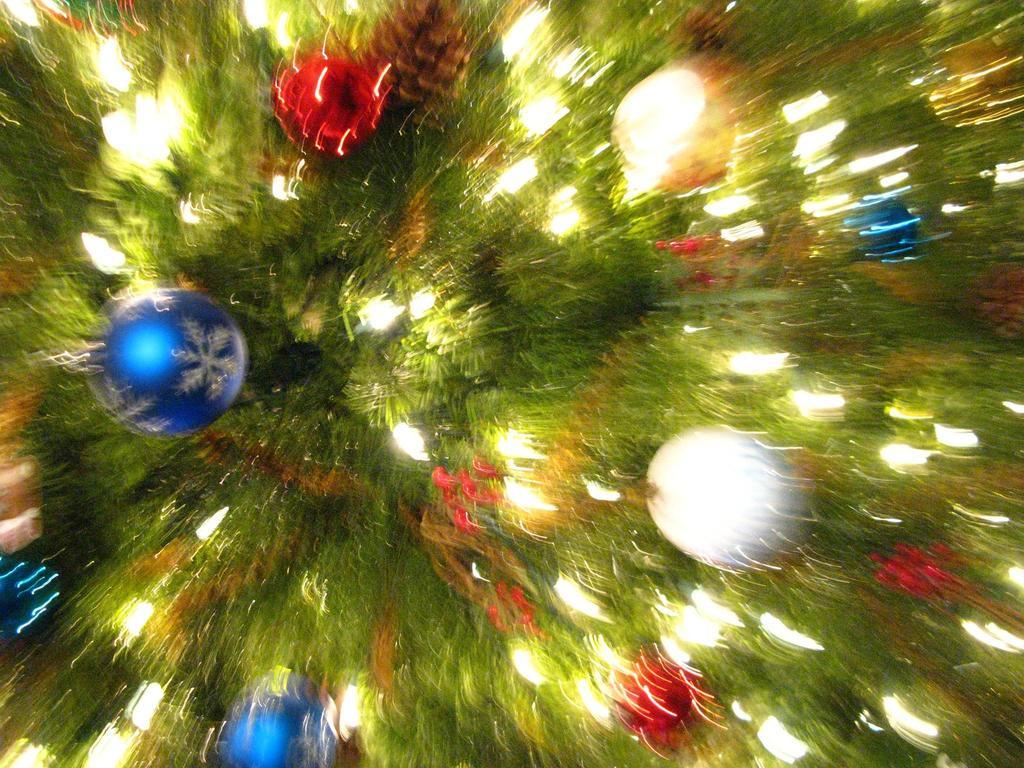Where is the grandmother's shelf for storing the fowl in the image? There is no shelf, fowl, or grandmother present in the image. 